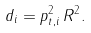Convert formula to latex. <formula><loc_0><loc_0><loc_500><loc_500>d _ { i } = p _ { t , i } ^ { 2 } \, R ^ { 2 } .</formula> 